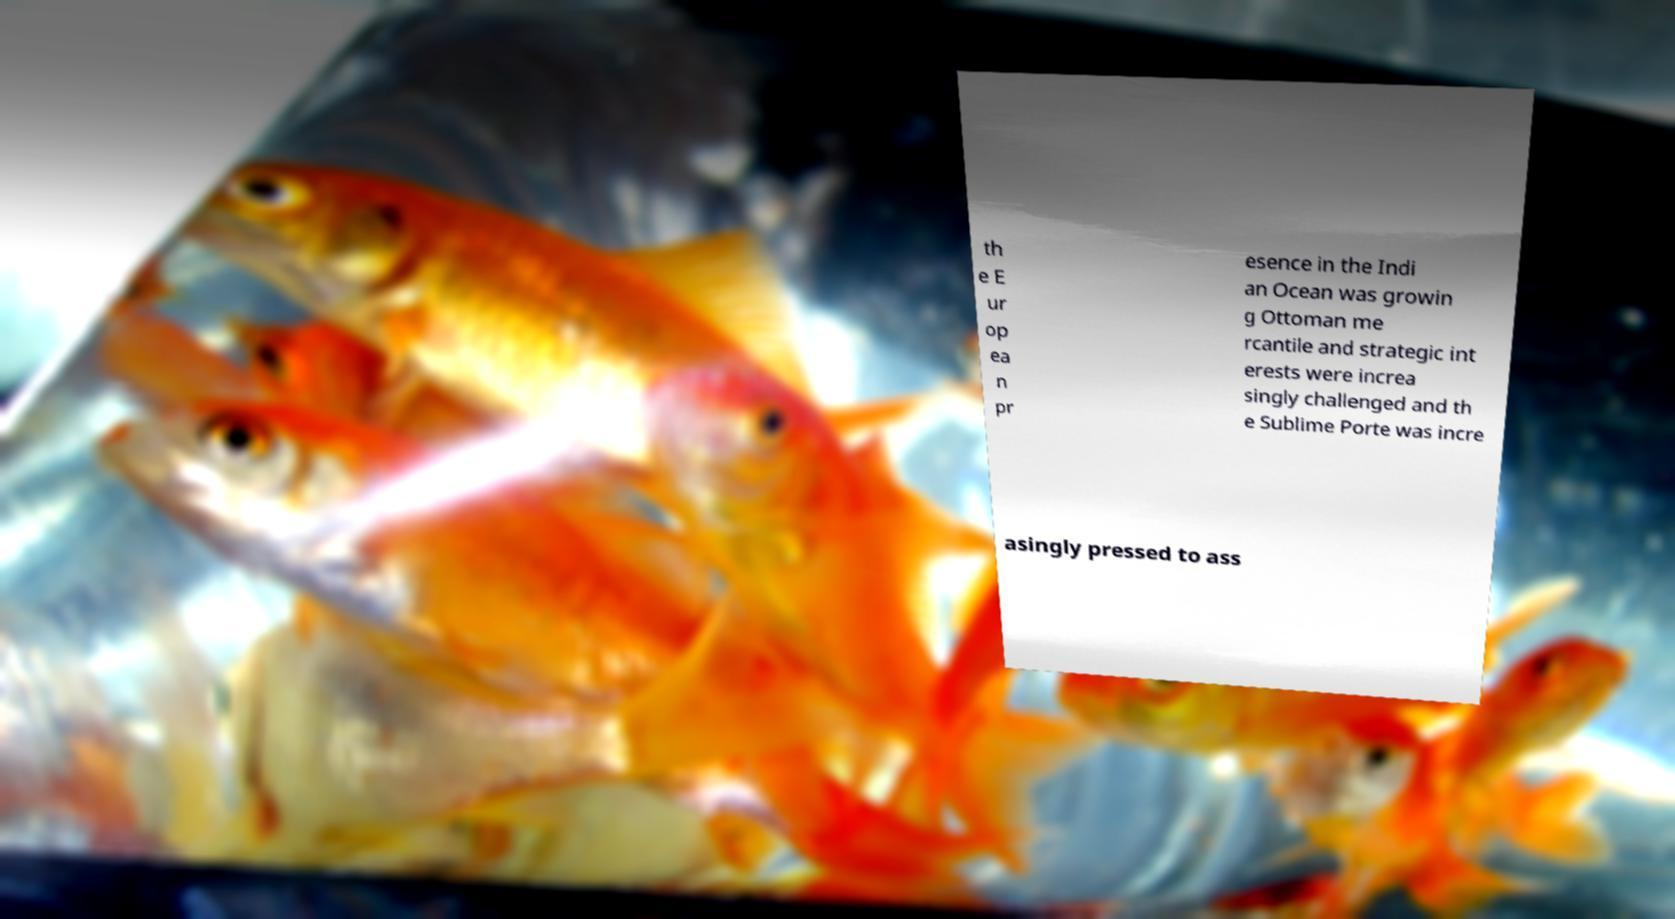Could you assist in decoding the text presented in this image and type it out clearly? th e E ur op ea n pr esence in the Indi an Ocean was growin g Ottoman me rcantile and strategic int erests were increa singly challenged and th e Sublime Porte was incre asingly pressed to ass 